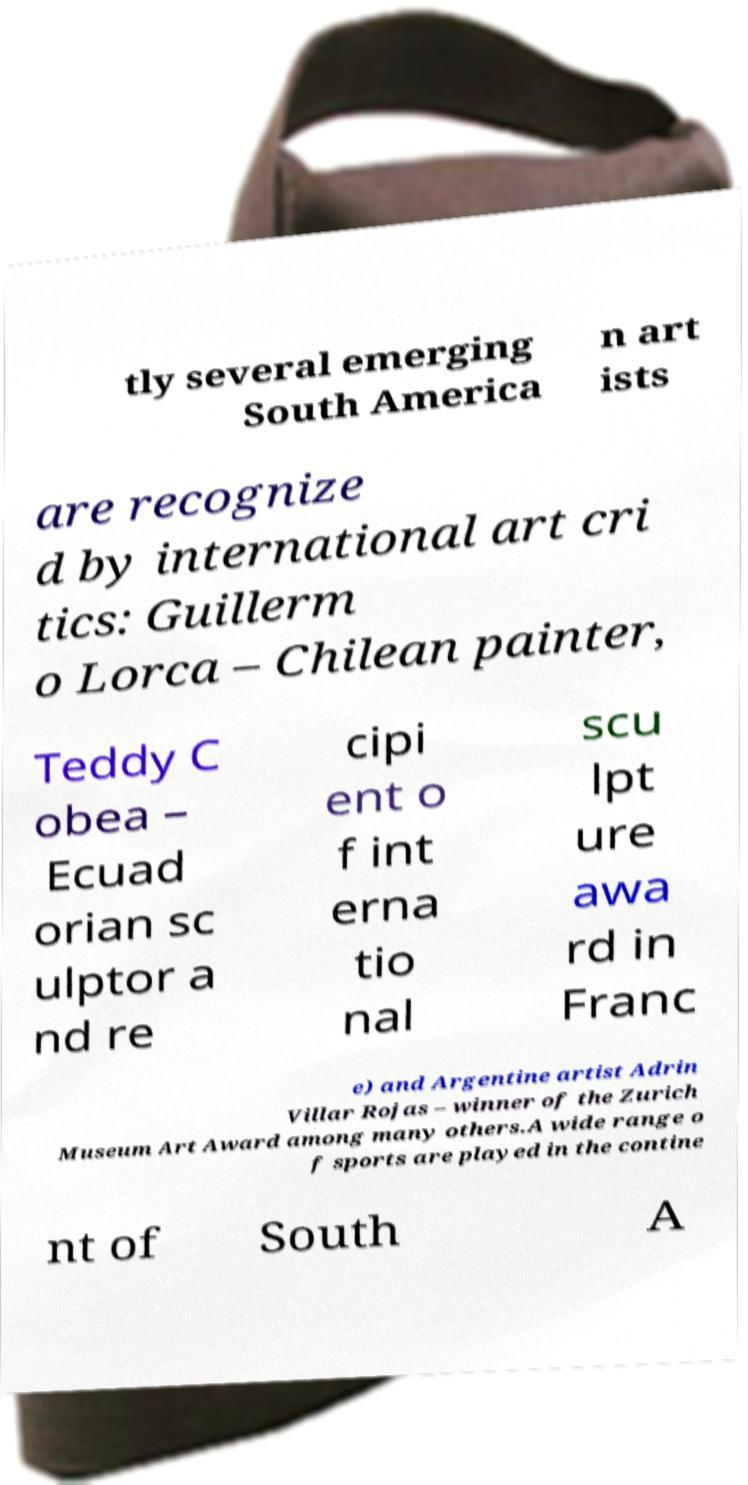Can you accurately transcribe the text from the provided image for me? tly several emerging South America n art ists are recognize d by international art cri tics: Guillerm o Lorca – Chilean painter, Teddy C obea – Ecuad orian sc ulptor a nd re cipi ent o f int erna tio nal scu lpt ure awa rd in Franc e) and Argentine artist Adrin Villar Rojas – winner of the Zurich Museum Art Award among many others.A wide range o f sports are played in the contine nt of South A 